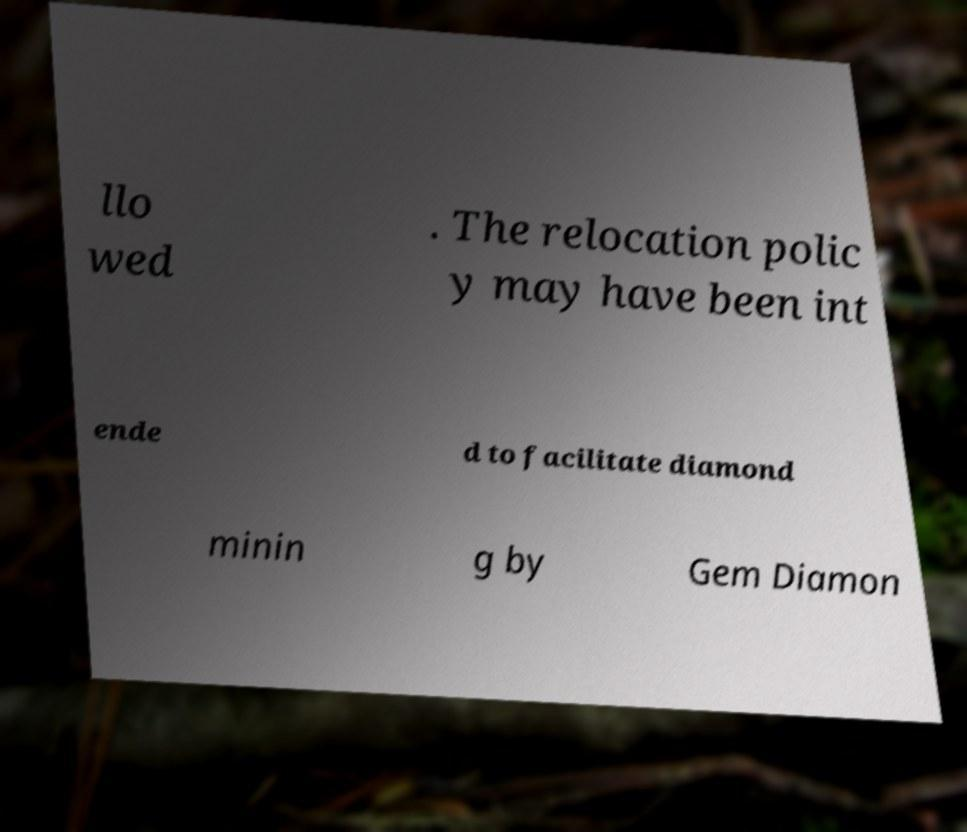Could you extract and type out the text from this image? llo wed . The relocation polic y may have been int ende d to facilitate diamond minin g by Gem Diamon 